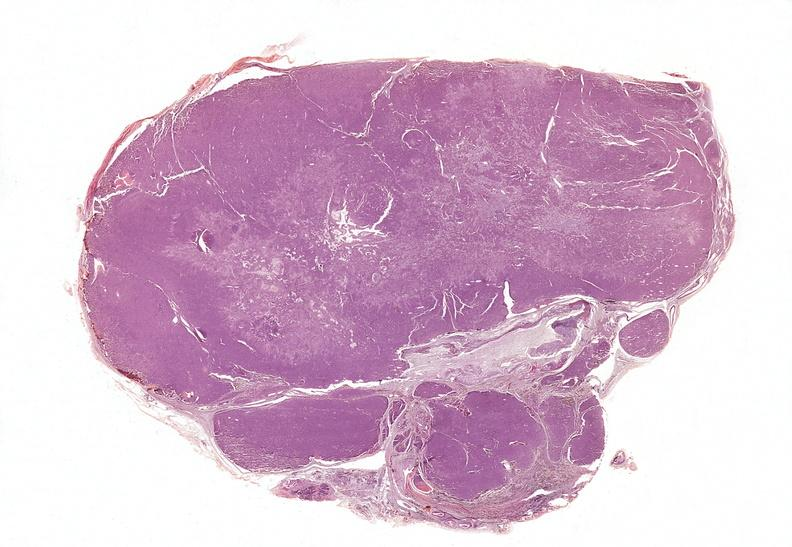what is present?
Answer the question using a single word or phrase. Endocrine 